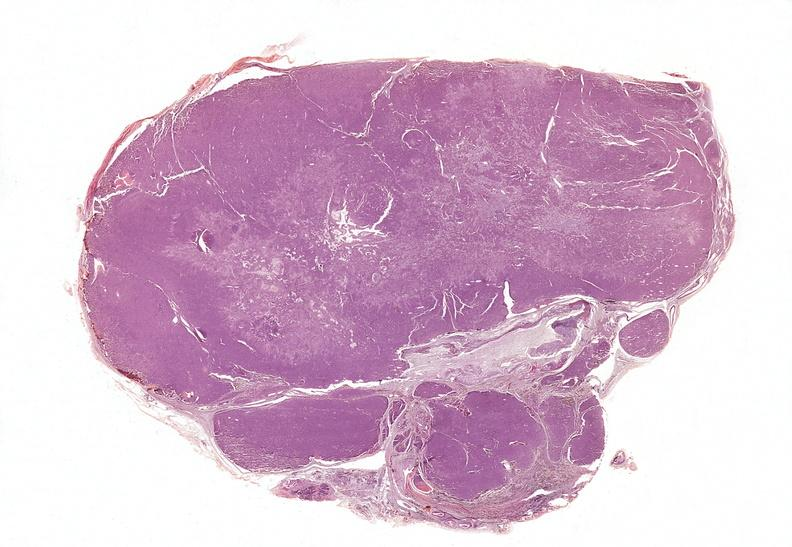what is present?
Answer the question using a single word or phrase. Endocrine 